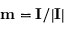Convert formula to latex. <formula><loc_0><loc_0><loc_500><loc_500>m = I / | I |</formula> 